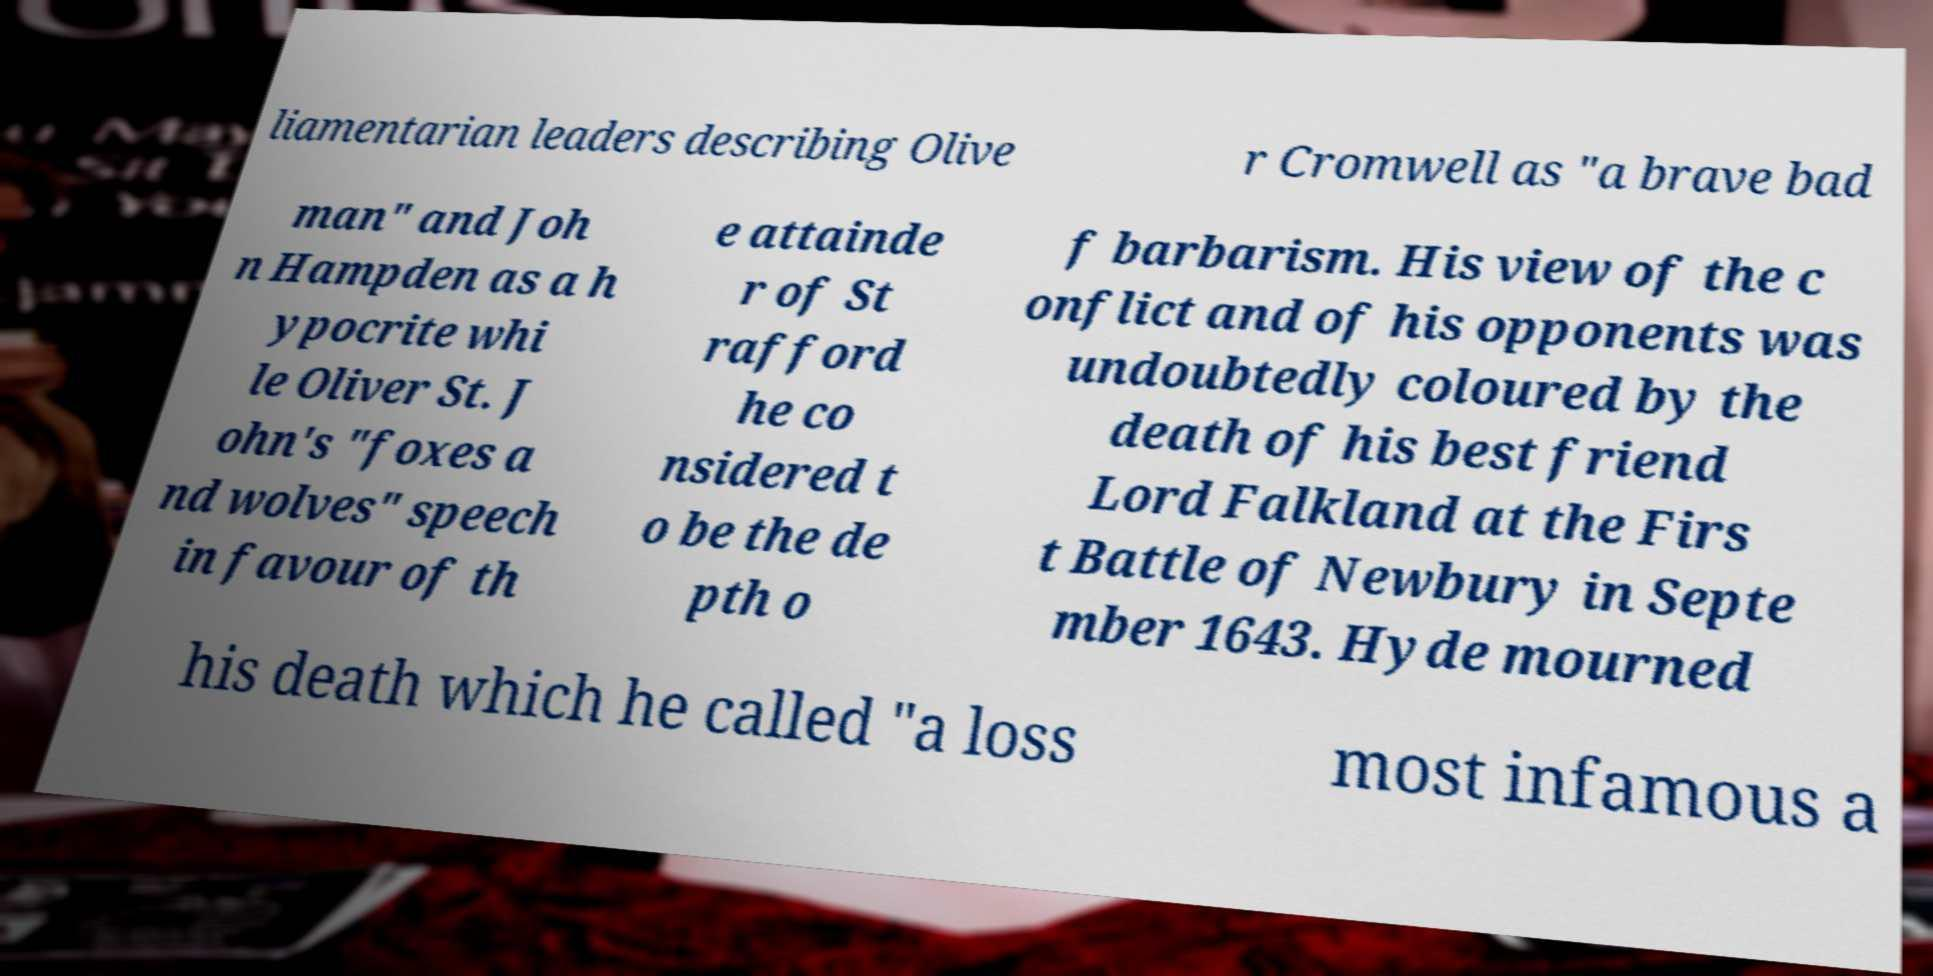I need the written content from this picture converted into text. Can you do that? liamentarian leaders describing Olive r Cromwell as "a brave bad man" and Joh n Hampden as a h ypocrite whi le Oliver St. J ohn's "foxes a nd wolves" speech in favour of th e attainde r of St rafford he co nsidered t o be the de pth o f barbarism. His view of the c onflict and of his opponents was undoubtedly coloured by the death of his best friend Lord Falkland at the Firs t Battle of Newbury in Septe mber 1643. Hyde mourned his death which he called "a loss most infamous a 